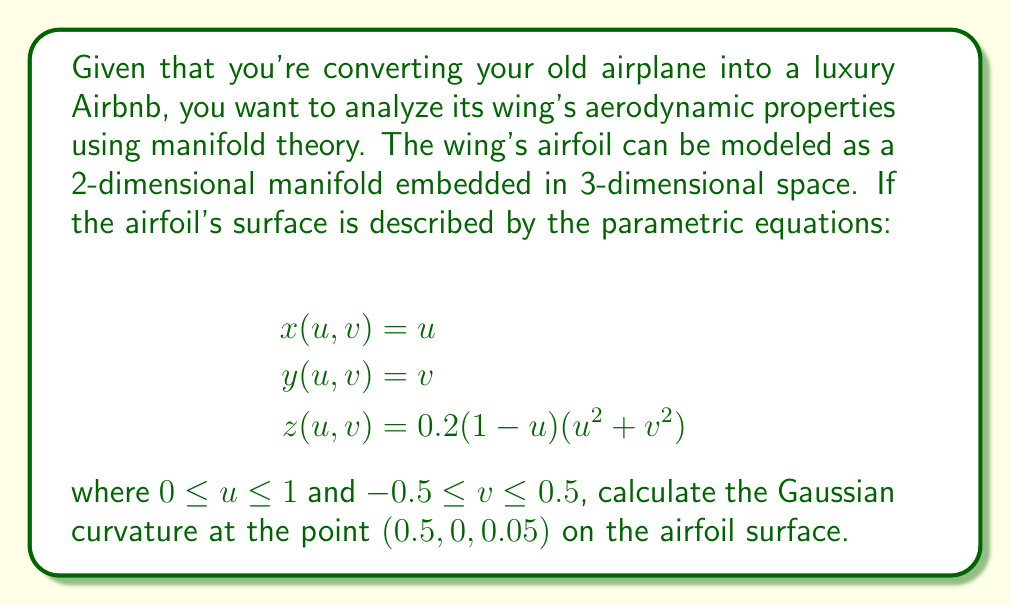Give your solution to this math problem. To find the Gaussian curvature of the airfoil surface at the given point, we need to follow these steps:

1) First, we need to calculate the partial derivatives of x, y, and z with respect to u and v:

   $$x_u = 1, x_v = 0$$
   $$y_u = 0, y_v = 1$$
   $$z_u = 0.2(-u^2 - v^2 + 2u - 1), z_v = 0.4v(1-u)$$

2) Now, we can compute the coefficients of the first fundamental form:

   $$E = x_u^2 + y_u^2 + z_u^2 = 1 + [0.2(-u^2 - v^2 + 2u - 1)]^2$$
   $$F = x_ux_v + y_uy_v + z_uz_v = 0.08v(1-u)(-u^2 - v^2 + 2u - 1)$$
   $$G = x_v^2 + y_v^2 + z_v^2 = 1 + [0.4v(1-u)]^2$$

3) Next, we need to calculate the second partial derivatives:

   $$z_{uu} = 0.4(u-1)$$
   $$z_{uv} = -0.4v$$
   $$z_{vv} = 0.4(1-u)$$

4) Now we can compute the coefficients of the second fundamental form. The normal vector to the surface is:

   $$\vec{N} = \frac{(x_u \times x_v)}{|(x_u \times x_v)|} = \frac{(-z_u, -z_v, 1)}{\sqrt{1 + z_u^2 + z_v^2}}$$

   The coefficients are:

   $$L = \frac{z_{uu}}{\sqrt{1 + z_u^2 + z_v^2}}$$
   $$M = \frac{z_{uv}}{\sqrt{1 + z_u^2 + z_v^2}}$$
   $$N = \frac{z_{vv}}{\sqrt{1 + z_u^2 + z_v^2}}$$

5) The Gaussian curvature is given by:

   $$K = \frac{LN - M^2}{EG - F^2}$$

6) At the point (0.5, 0, 0.05), we have u = 0.5, v = 0. Substituting these values:

   $$E = 1 + [0.2(-0.5^2 - 0^2 + 2(0.5) - 1)]^2 = 1$$
   $$F = 0$$
   $$G = 1$$
   $$L = \frac{0.4(0.5-1)}{\sqrt{1 + 0^2 + 0^2}} = -0.2$$
   $$M = 0$$
   $$N = \frac{0.4(1-0.5)}{\sqrt{1 + 0^2 + 0^2}} = 0.2$$

7) Finally, we can calculate the Gaussian curvature:

   $$K = \frac{(-0.2)(0.2) - 0^2}{(1)(1) - 0^2} = -0.04$$
Answer: The Gaussian curvature of the airfoil surface at the point (0.5, 0, 0.05) is $-0.04$. 